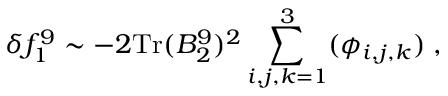Convert formula to latex. <formula><loc_0><loc_0><loc_500><loc_500>\delta f _ { 1 } ^ { 9 } \sim - 2 T r ( B _ { 2 } ^ { 9 } ) ^ { 2 } \sum _ { i , j , k = 1 } ^ { 3 } ( \phi _ { i , j , k } ) \, ,</formula> 